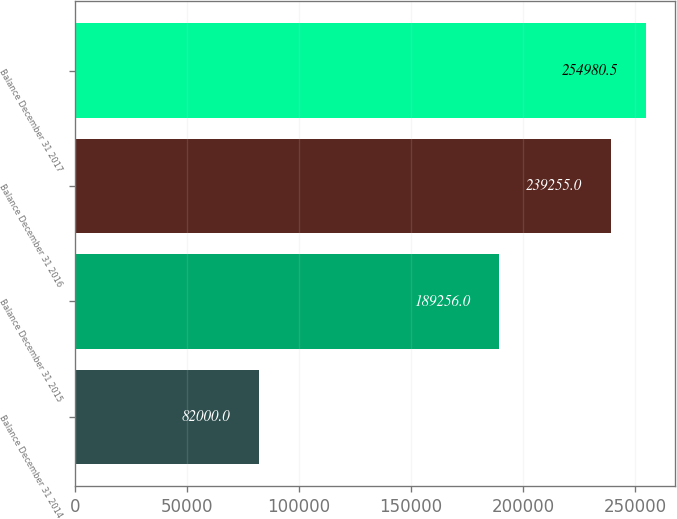<chart> <loc_0><loc_0><loc_500><loc_500><bar_chart><fcel>Balance December 31 2014<fcel>Balance December 31 2015<fcel>Balance December 31 2016<fcel>Balance December 31 2017<nl><fcel>82000<fcel>189256<fcel>239255<fcel>254980<nl></chart> 